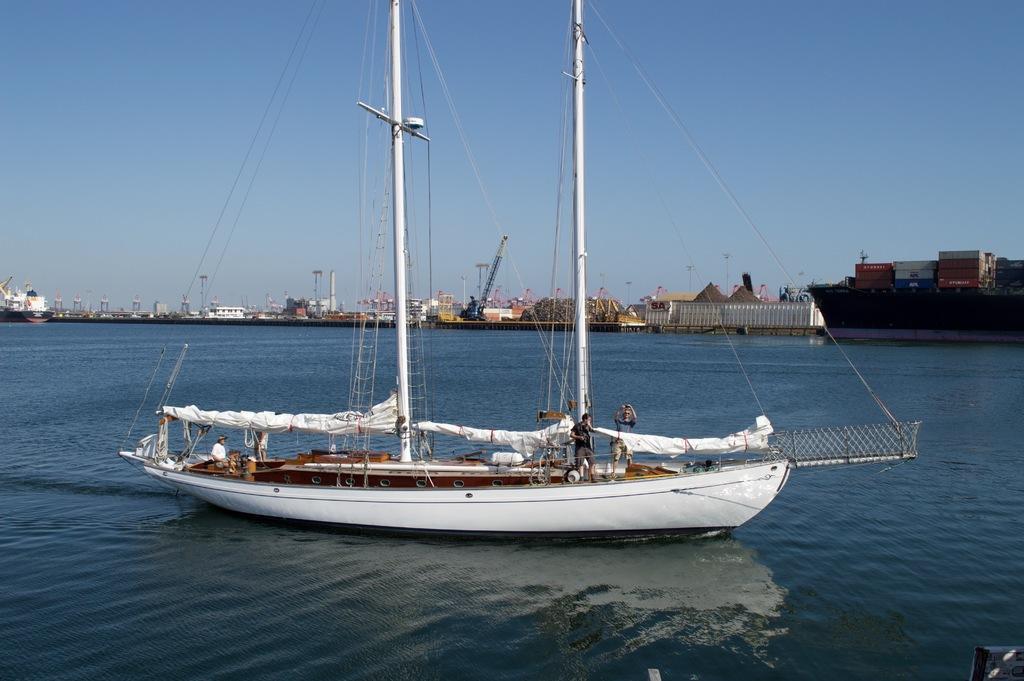Can you describe this image briefly? In the image it looks like a yacht on a water surface, there are two poles and many wires on the ship and in the background there are many boats, some compartments and other things. 